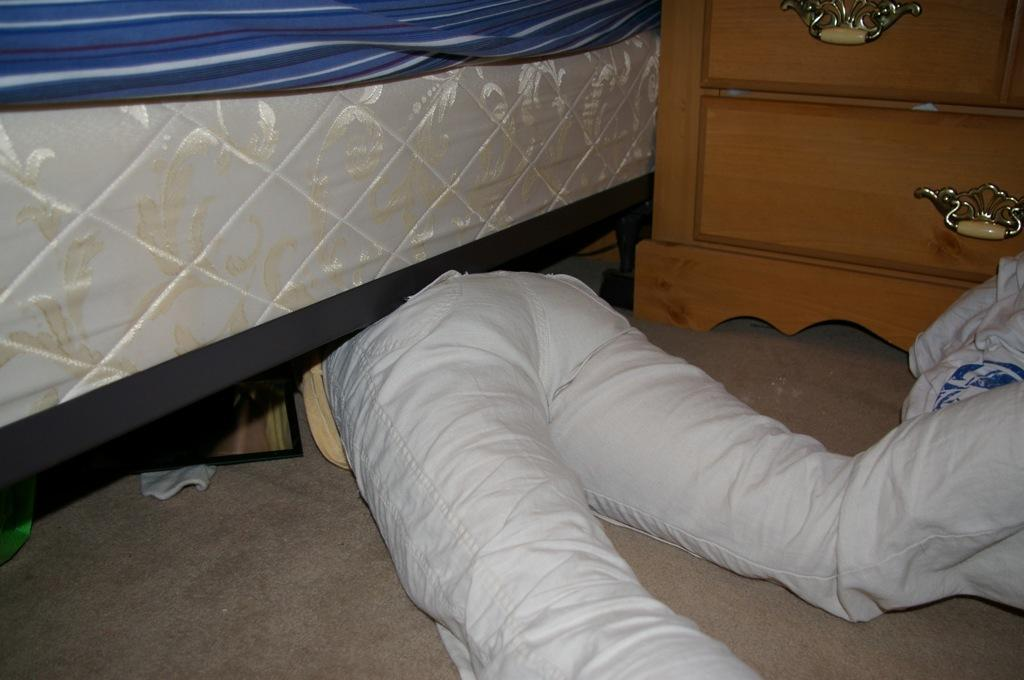Where is the setting of the image? The image is inside a room. What is the position of the person in the image? The person is lying on the floor and is under the bed. What furniture is present in the room? There is a table in the room. What is the color of the bed sheet on the mattress? The bed sheet on the mattress is blue in color. How many cows are visible in the image? There are no cows present in the image. What is the value of the cent in the image? There is no cent present in the image. 